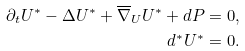Convert formula to latex. <formula><loc_0><loc_0><loc_500><loc_500>\partial _ { t } U ^ { * } - \Delta U ^ { * } + \overline { \nabla } _ { U } U ^ { * } + d P & = 0 , \\ d ^ { \ast } U ^ { \ast } & = 0 .</formula> 